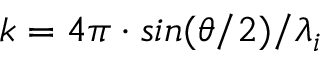Convert formula to latex. <formula><loc_0><loc_0><loc_500><loc_500>k = 4 \pi \cdot \sin ( \theta / 2 ) / \lambda _ { i }</formula> 